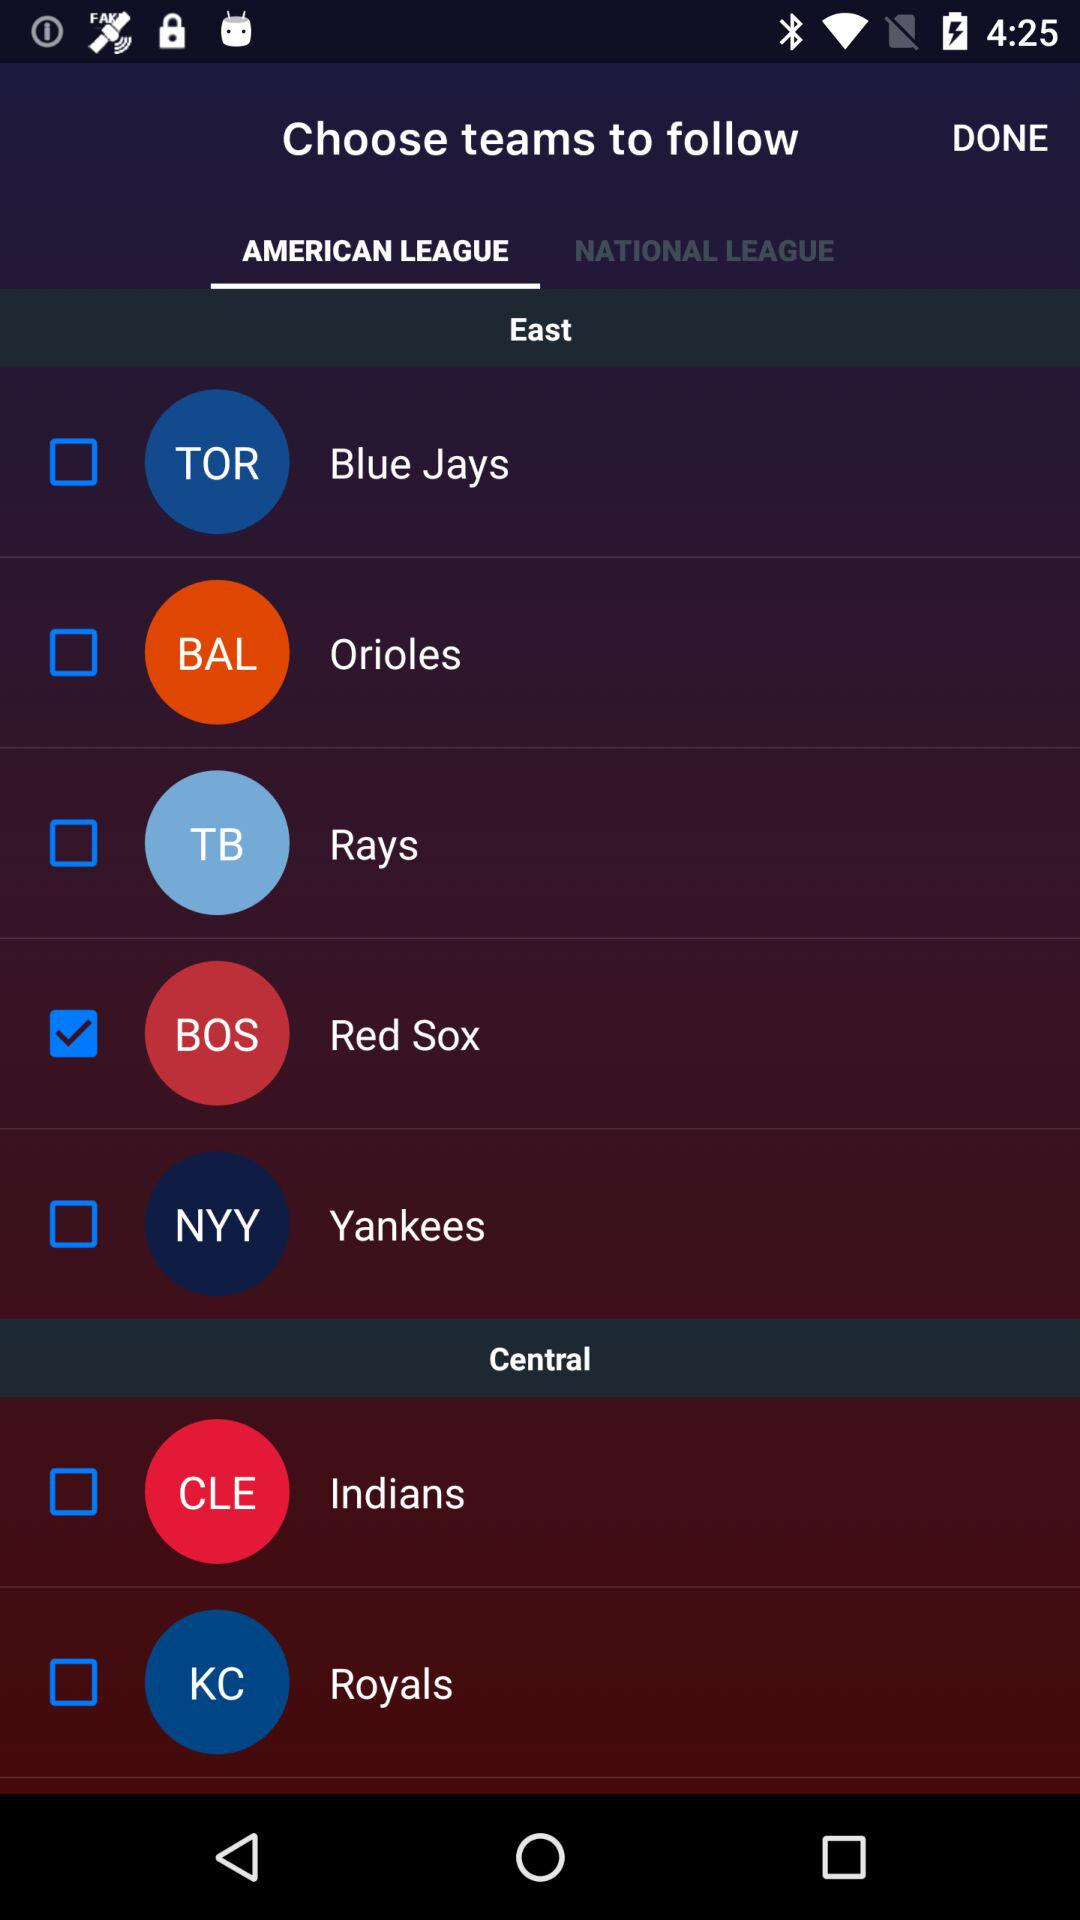How many teams are in the Central division?
Answer the question using a single word or phrase. 2 